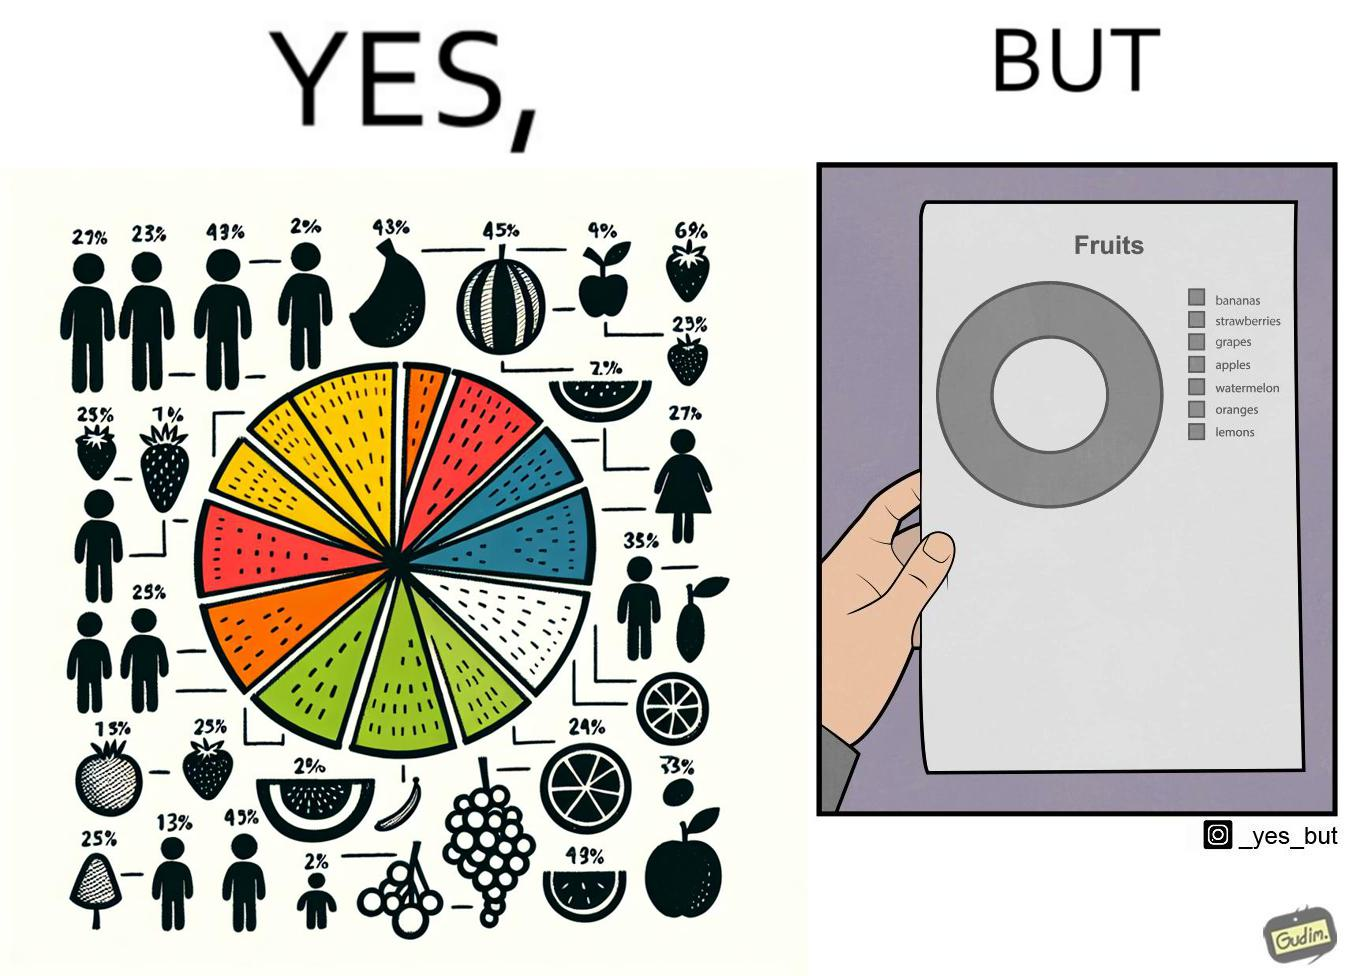Describe what you see in the left and right parts of this image. In the left part of the image: A colorful pie chart titled "Fruits", with different distributions of various fruits like bananas, strawberries, grapes, apples, watermelon, oranges and lemons. In the right part of the image: A BLACK and WHITE greyscale printout of a pie chart titled "Fruits". The pie chart is just one circle with no divisions, but there is a key beside it that mentions various fruits like bananas, strawberries, grapes, apples, watermelon, oranges and lemons. 